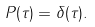Convert formula to latex. <formula><loc_0><loc_0><loc_500><loc_500>P ( \tau ) = \delta ( \tau ) .</formula> 